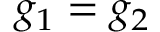<formula> <loc_0><loc_0><loc_500><loc_500>g _ { 1 } = g _ { 2 }</formula> 